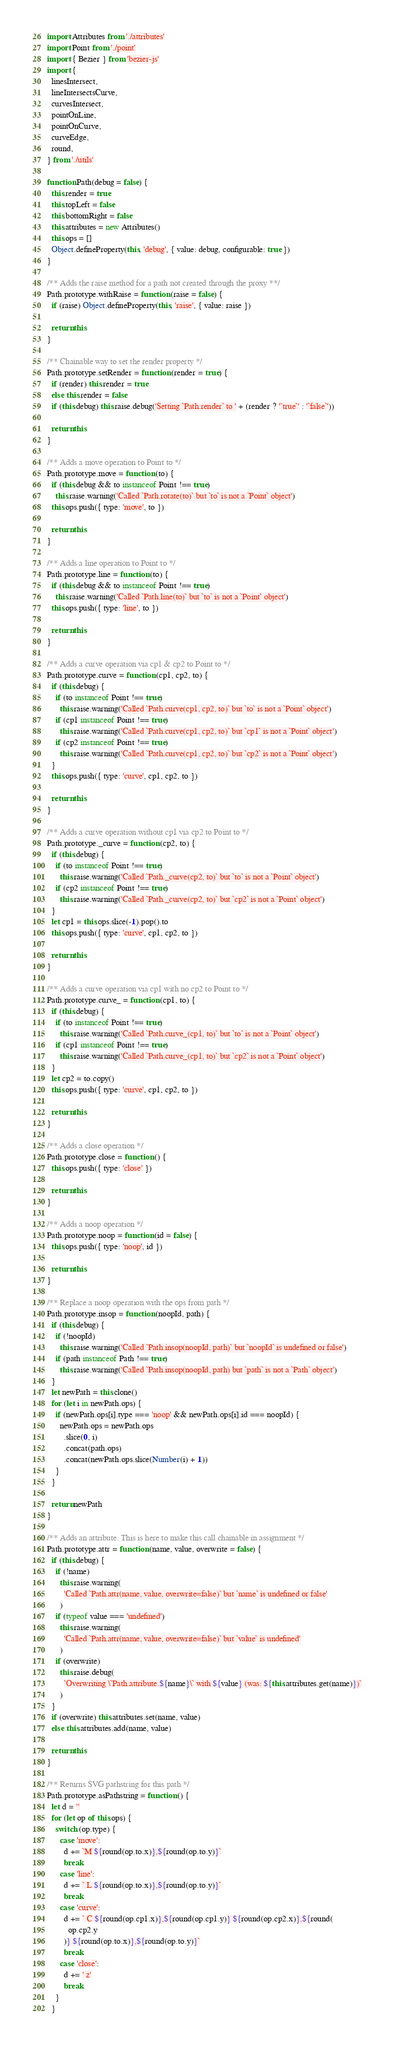<code> <loc_0><loc_0><loc_500><loc_500><_JavaScript_>import Attributes from './attributes'
import Point from './point'
import { Bezier } from 'bezier-js'
import {
  linesIntersect,
  lineIntersectsCurve,
  curvesIntersect,
  pointOnLine,
  pointOnCurve,
  curveEdge,
  round,
} from './utils'

function Path(debug = false) {
  this.render = true
  this.topLeft = false
  this.bottomRight = false
  this.attributes = new Attributes()
  this.ops = []
  Object.defineProperty(this, 'debug', { value: debug, configurable: true })
}

/** Adds the raise method for a path not created through the proxy **/
Path.prototype.withRaise = function (raise = false) {
  if (raise) Object.defineProperty(this, 'raise', { value: raise })

  return this
}

/** Chainable way to set the render property */
Path.prototype.setRender = function (render = true) {
  if (render) this.render = true
  else this.render = false
  if (this.debug) this.raise.debug('Setting `Path.render` to ' + (render ? '`true`' : '`false`'))

  return this
}

/** Adds a move operation to Point to */
Path.prototype.move = function (to) {
  if (this.debug && to instanceof Point !== true)
    this.raise.warning('Called `Path.rotate(to)` but `to` is not a `Point` object')
  this.ops.push({ type: 'move', to })

  return this
}

/** Adds a line operation to Point to */
Path.prototype.line = function (to) {
  if (this.debug && to instanceof Point !== true)
    this.raise.warning('Called `Path.line(to)` but `to` is not a `Point` object')
  this.ops.push({ type: 'line', to })

  return this
}

/** Adds a curve operation via cp1 & cp2 to Point to */
Path.prototype.curve = function (cp1, cp2, to) {
  if (this.debug) {
    if (to instanceof Point !== true)
      this.raise.warning('Called `Path.curve(cp1, cp2, to)` but `to` is not a `Point` object')
    if (cp1 instanceof Point !== true)
      this.raise.warning('Called `Path.curve(cp1, cp2, to)` but `cp1` is not a `Point` object')
    if (cp2 instanceof Point !== true)
      this.raise.warning('Called `Path.curve(cp1, cp2, to)` but `cp2` is not a `Point` object')
  }
  this.ops.push({ type: 'curve', cp1, cp2, to })

  return this
}

/** Adds a curve operation without cp1 via cp2 to Point to */
Path.prototype._curve = function (cp2, to) {
  if (this.debug) {
    if (to instanceof Point !== true)
      this.raise.warning('Called `Path._curve(cp2, to)` but `to` is not a `Point` object')
    if (cp2 instanceof Point !== true)
      this.raise.warning('Called `Path._curve(cp2, to)` but `cp2` is not a `Point` object')
  }
  let cp1 = this.ops.slice(-1).pop().to
  this.ops.push({ type: 'curve', cp1, cp2, to })

  return this
}

/** Adds a curve operation via cp1 with no cp2 to Point to */
Path.prototype.curve_ = function (cp1, to) {
  if (this.debug) {
    if (to instanceof Point !== true)
      this.raise.warning('Called `Path.curve_(cp1, to)` but `to` is not a `Point` object')
    if (cp1 instanceof Point !== true)
      this.raise.warning('Called `Path.curve_(cp1, to)` but `cp2` is not a `Point` object')
  }
  let cp2 = to.copy()
  this.ops.push({ type: 'curve', cp1, cp2, to })

  return this
}

/** Adds a close operation */
Path.prototype.close = function () {
  this.ops.push({ type: 'close' })

  return this
}

/** Adds a noop operation */
Path.prototype.noop = function (id = false) {
  this.ops.push({ type: 'noop', id })

  return this
}

/** Replace a noop operation with the ops from path */
Path.prototype.insop = function (noopId, path) {
  if (this.debug) {
    if (!noopId)
      this.raise.warning('Called `Path.insop(noopId, path)` but `noopId` is undefined or false')
    if (path instanceof Path !== true)
      this.raise.warning('Called `Path.insop(noopId, path) but `path` is not a `Path` object')
  }
  let newPath = this.clone()
  for (let i in newPath.ops) {
    if (newPath.ops[i].type === 'noop' && newPath.ops[i].id === noopId) {
      newPath.ops = newPath.ops
        .slice(0, i)
        .concat(path.ops)
        .concat(newPath.ops.slice(Number(i) + 1))
    }
  }

  return newPath
}

/** Adds an attribute. This is here to make this call chainable in assignment */
Path.prototype.attr = function (name, value, overwrite = false) {
  if (this.debug) {
    if (!name)
      this.raise.warning(
        'Called `Path.attr(name, value, overwrite=false)` but `name` is undefined or false'
      )
    if (typeof value === 'undefined')
      this.raise.warning(
        'Called `Path.attr(name, value, overwrite=false)` but `value` is undefined'
      )
    if (overwrite)
      this.raise.debug(
        `Overwriting \`Path.attribute.${name}\` with ${value} (was: ${this.attributes.get(name)})`
      )
  }
  if (overwrite) this.attributes.set(name, value)
  else this.attributes.add(name, value)

  return this
}

/** Returns SVG pathstring for this path */
Path.prototype.asPathstring = function () {
  let d = ''
  for (let op of this.ops) {
    switch (op.type) {
      case 'move':
        d += `M ${round(op.to.x)},${round(op.to.y)}`
        break
      case 'line':
        d += ` L ${round(op.to.x)},${round(op.to.y)}`
        break
      case 'curve':
        d += ` C ${round(op.cp1.x)},${round(op.cp1.y)} ${round(op.cp2.x)},${round(
          op.cp2.y
        )} ${round(op.to.x)},${round(op.to.y)}`
        break
      case 'close':
        d += ' z'
        break
    }
  }
</code> 